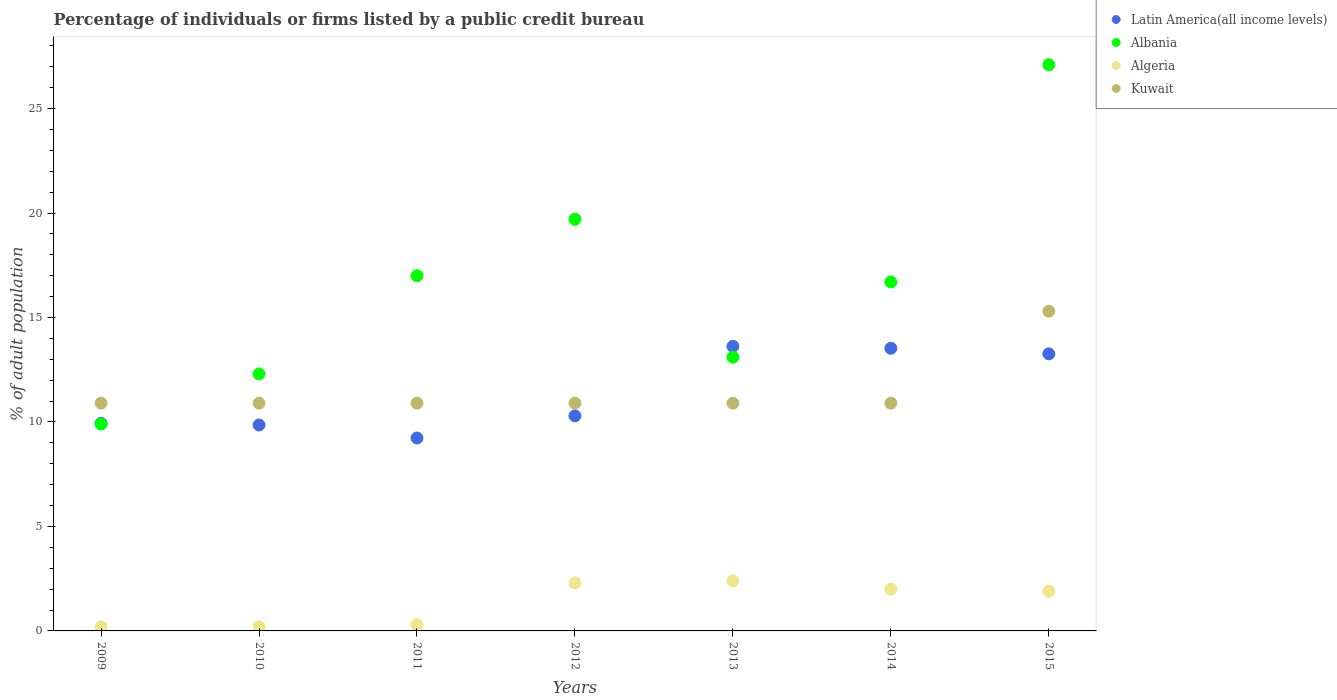Is the number of dotlines equal to the number of legend labels?
Give a very brief answer. Yes. Across all years, what is the maximum percentage of population listed by a public credit bureau in Albania?
Your answer should be very brief. 27.1. In which year was the percentage of population listed by a public credit bureau in Kuwait minimum?
Keep it short and to the point. 2009. What is the total percentage of population listed by a public credit bureau in Algeria in the graph?
Give a very brief answer. 9.3. What is the difference between the percentage of population listed by a public credit bureau in Latin America(all income levels) in 2011 and that in 2013?
Provide a succinct answer. -4.39. What is the difference between the percentage of population listed by a public credit bureau in Latin America(all income levels) in 2013 and the percentage of population listed by a public credit bureau in Albania in 2012?
Ensure brevity in your answer.  -6.08. What is the average percentage of population listed by a public credit bureau in Albania per year?
Ensure brevity in your answer.  16.54. In the year 2015, what is the difference between the percentage of population listed by a public credit bureau in Latin America(all income levels) and percentage of population listed by a public credit bureau in Albania?
Make the answer very short. -13.84. Is the difference between the percentage of population listed by a public credit bureau in Latin America(all income levels) in 2009 and 2014 greater than the difference between the percentage of population listed by a public credit bureau in Albania in 2009 and 2014?
Offer a terse response. Yes. What is the difference between the highest and the lowest percentage of population listed by a public credit bureau in Algeria?
Give a very brief answer. 2.2. Is the sum of the percentage of population listed by a public credit bureau in Kuwait in 2009 and 2012 greater than the maximum percentage of population listed by a public credit bureau in Algeria across all years?
Provide a short and direct response. Yes. Is it the case that in every year, the sum of the percentage of population listed by a public credit bureau in Kuwait and percentage of population listed by a public credit bureau in Latin America(all income levels)  is greater than the sum of percentage of population listed by a public credit bureau in Algeria and percentage of population listed by a public credit bureau in Albania?
Your answer should be compact. No. Is the percentage of population listed by a public credit bureau in Latin America(all income levels) strictly greater than the percentage of population listed by a public credit bureau in Albania over the years?
Give a very brief answer. No. Is the percentage of population listed by a public credit bureau in Kuwait strictly less than the percentage of population listed by a public credit bureau in Albania over the years?
Provide a succinct answer. No. How many years are there in the graph?
Your answer should be very brief. 7. Where does the legend appear in the graph?
Provide a short and direct response. Top right. What is the title of the graph?
Keep it short and to the point. Percentage of individuals or firms listed by a public credit bureau. What is the label or title of the X-axis?
Your answer should be very brief. Years. What is the label or title of the Y-axis?
Your answer should be compact. % of adult population. What is the % of adult population of Latin America(all income levels) in 2009?
Provide a short and direct response. 9.93. What is the % of adult population in Latin America(all income levels) in 2010?
Keep it short and to the point. 9.86. What is the % of adult population in Albania in 2010?
Offer a very short reply. 12.3. What is the % of adult population in Algeria in 2010?
Offer a very short reply. 0.2. What is the % of adult population in Kuwait in 2010?
Offer a very short reply. 10.9. What is the % of adult population of Latin America(all income levels) in 2011?
Your response must be concise. 9.23. What is the % of adult population in Kuwait in 2011?
Offer a terse response. 10.9. What is the % of adult population of Latin America(all income levels) in 2012?
Your answer should be very brief. 10.29. What is the % of adult population of Kuwait in 2012?
Offer a terse response. 10.9. What is the % of adult population in Latin America(all income levels) in 2013?
Provide a short and direct response. 13.62. What is the % of adult population of Albania in 2013?
Make the answer very short. 13.1. What is the % of adult population in Latin America(all income levels) in 2014?
Your response must be concise. 13.53. What is the % of adult population in Albania in 2014?
Offer a terse response. 16.7. What is the % of adult population of Algeria in 2014?
Keep it short and to the point. 2. What is the % of adult population in Kuwait in 2014?
Provide a short and direct response. 10.9. What is the % of adult population in Latin America(all income levels) in 2015?
Offer a very short reply. 13.26. What is the % of adult population of Albania in 2015?
Offer a very short reply. 27.1. Across all years, what is the maximum % of adult population in Latin America(all income levels)?
Give a very brief answer. 13.62. Across all years, what is the maximum % of adult population in Albania?
Your response must be concise. 27.1. Across all years, what is the maximum % of adult population in Algeria?
Your response must be concise. 2.4. Across all years, what is the maximum % of adult population in Kuwait?
Offer a very short reply. 15.3. Across all years, what is the minimum % of adult population of Latin America(all income levels)?
Your answer should be very brief. 9.23. Across all years, what is the minimum % of adult population in Albania?
Keep it short and to the point. 9.9. Across all years, what is the minimum % of adult population in Algeria?
Offer a terse response. 0.2. What is the total % of adult population of Latin America(all income levels) in the graph?
Keep it short and to the point. 79.72. What is the total % of adult population in Albania in the graph?
Offer a terse response. 115.8. What is the total % of adult population in Kuwait in the graph?
Ensure brevity in your answer.  80.7. What is the difference between the % of adult population of Latin America(all income levels) in 2009 and that in 2010?
Keep it short and to the point. 0.08. What is the difference between the % of adult population of Kuwait in 2009 and that in 2010?
Make the answer very short. 0. What is the difference between the % of adult population of Latin America(all income levels) in 2009 and that in 2011?
Your answer should be very brief. 0.7. What is the difference between the % of adult population of Albania in 2009 and that in 2011?
Provide a succinct answer. -7.1. What is the difference between the % of adult population in Latin America(all income levels) in 2009 and that in 2012?
Provide a short and direct response. -0.36. What is the difference between the % of adult population of Albania in 2009 and that in 2012?
Keep it short and to the point. -9.8. What is the difference between the % of adult population of Algeria in 2009 and that in 2012?
Provide a succinct answer. -2.1. What is the difference between the % of adult population in Latin America(all income levels) in 2009 and that in 2013?
Your answer should be compact. -3.68. What is the difference between the % of adult population of Latin America(all income levels) in 2009 and that in 2014?
Offer a very short reply. -3.59. What is the difference between the % of adult population of Algeria in 2009 and that in 2014?
Offer a terse response. -1.8. What is the difference between the % of adult population of Latin America(all income levels) in 2009 and that in 2015?
Keep it short and to the point. -3.33. What is the difference between the % of adult population of Albania in 2009 and that in 2015?
Provide a short and direct response. -17.2. What is the difference between the % of adult population of Algeria in 2009 and that in 2015?
Provide a succinct answer. -1.7. What is the difference between the % of adult population in Latin America(all income levels) in 2010 and that in 2011?
Offer a very short reply. 0.62. What is the difference between the % of adult population of Albania in 2010 and that in 2011?
Ensure brevity in your answer.  -4.7. What is the difference between the % of adult population of Latin America(all income levels) in 2010 and that in 2012?
Provide a short and direct response. -0.44. What is the difference between the % of adult population of Algeria in 2010 and that in 2012?
Your answer should be compact. -2.1. What is the difference between the % of adult population of Kuwait in 2010 and that in 2012?
Make the answer very short. 0. What is the difference between the % of adult population in Latin America(all income levels) in 2010 and that in 2013?
Your answer should be compact. -3.76. What is the difference between the % of adult population in Algeria in 2010 and that in 2013?
Provide a succinct answer. -2.2. What is the difference between the % of adult population in Kuwait in 2010 and that in 2013?
Give a very brief answer. 0. What is the difference between the % of adult population of Latin America(all income levels) in 2010 and that in 2014?
Your answer should be very brief. -3.67. What is the difference between the % of adult population in Latin America(all income levels) in 2010 and that in 2015?
Provide a succinct answer. -3.4. What is the difference between the % of adult population in Albania in 2010 and that in 2015?
Your response must be concise. -14.8. What is the difference between the % of adult population of Kuwait in 2010 and that in 2015?
Your answer should be very brief. -4.4. What is the difference between the % of adult population in Latin America(all income levels) in 2011 and that in 2012?
Provide a succinct answer. -1.06. What is the difference between the % of adult population of Latin America(all income levels) in 2011 and that in 2013?
Give a very brief answer. -4.39. What is the difference between the % of adult population of Latin America(all income levels) in 2011 and that in 2014?
Offer a very short reply. -4.29. What is the difference between the % of adult population of Algeria in 2011 and that in 2014?
Give a very brief answer. -1.7. What is the difference between the % of adult population in Kuwait in 2011 and that in 2014?
Offer a terse response. 0. What is the difference between the % of adult population of Latin America(all income levels) in 2011 and that in 2015?
Provide a short and direct response. -4.03. What is the difference between the % of adult population in Albania in 2011 and that in 2015?
Provide a succinct answer. -10.1. What is the difference between the % of adult population of Latin America(all income levels) in 2012 and that in 2013?
Give a very brief answer. -3.32. What is the difference between the % of adult population of Albania in 2012 and that in 2013?
Make the answer very short. 6.6. What is the difference between the % of adult population in Algeria in 2012 and that in 2013?
Ensure brevity in your answer.  -0.1. What is the difference between the % of adult population of Kuwait in 2012 and that in 2013?
Offer a very short reply. 0. What is the difference between the % of adult population in Latin America(all income levels) in 2012 and that in 2014?
Offer a terse response. -3.23. What is the difference between the % of adult population in Algeria in 2012 and that in 2014?
Keep it short and to the point. 0.3. What is the difference between the % of adult population of Latin America(all income levels) in 2012 and that in 2015?
Keep it short and to the point. -2.97. What is the difference between the % of adult population in Albania in 2012 and that in 2015?
Make the answer very short. -7.4. What is the difference between the % of adult population of Algeria in 2012 and that in 2015?
Provide a short and direct response. 0.4. What is the difference between the % of adult population in Latin America(all income levels) in 2013 and that in 2014?
Ensure brevity in your answer.  0.09. What is the difference between the % of adult population in Latin America(all income levels) in 2013 and that in 2015?
Ensure brevity in your answer.  0.36. What is the difference between the % of adult population in Albania in 2013 and that in 2015?
Give a very brief answer. -14. What is the difference between the % of adult population of Algeria in 2013 and that in 2015?
Your answer should be compact. 0.5. What is the difference between the % of adult population of Kuwait in 2013 and that in 2015?
Your response must be concise. -4.4. What is the difference between the % of adult population of Latin America(all income levels) in 2014 and that in 2015?
Your answer should be compact. 0.27. What is the difference between the % of adult population of Albania in 2014 and that in 2015?
Offer a terse response. -10.4. What is the difference between the % of adult population in Latin America(all income levels) in 2009 and the % of adult population in Albania in 2010?
Your answer should be very brief. -2.37. What is the difference between the % of adult population of Latin America(all income levels) in 2009 and the % of adult population of Algeria in 2010?
Ensure brevity in your answer.  9.73. What is the difference between the % of adult population in Latin America(all income levels) in 2009 and the % of adult population in Kuwait in 2010?
Offer a terse response. -0.97. What is the difference between the % of adult population of Albania in 2009 and the % of adult population of Kuwait in 2010?
Offer a terse response. -1. What is the difference between the % of adult population in Latin America(all income levels) in 2009 and the % of adult population in Albania in 2011?
Your answer should be very brief. -7.07. What is the difference between the % of adult population of Latin America(all income levels) in 2009 and the % of adult population of Algeria in 2011?
Offer a very short reply. 9.63. What is the difference between the % of adult population in Latin America(all income levels) in 2009 and the % of adult population in Kuwait in 2011?
Offer a very short reply. -0.97. What is the difference between the % of adult population of Albania in 2009 and the % of adult population of Kuwait in 2011?
Offer a very short reply. -1. What is the difference between the % of adult population of Algeria in 2009 and the % of adult population of Kuwait in 2011?
Your answer should be very brief. -10.7. What is the difference between the % of adult population of Latin America(all income levels) in 2009 and the % of adult population of Albania in 2012?
Keep it short and to the point. -9.77. What is the difference between the % of adult population of Latin America(all income levels) in 2009 and the % of adult population of Algeria in 2012?
Provide a short and direct response. 7.63. What is the difference between the % of adult population in Latin America(all income levels) in 2009 and the % of adult population in Kuwait in 2012?
Your response must be concise. -0.97. What is the difference between the % of adult population of Albania in 2009 and the % of adult population of Kuwait in 2012?
Offer a terse response. -1. What is the difference between the % of adult population in Algeria in 2009 and the % of adult population in Kuwait in 2012?
Offer a very short reply. -10.7. What is the difference between the % of adult population of Latin America(all income levels) in 2009 and the % of adult population of Albania in 2013?
Make the answer very short. -3.17. What is the difference between the % of adult population of Latin America(all income levels) in 2009 and the % of adult population of Algeria in 2013?
Provide a succinct answer. 7.53. What is the difference between the % of adult population in Latin America(all income levels) in 2009 and the % of adult population in Kuwait in 2013?
Offer a very short reply. -0.97. What is the difference between the % of adult population in Albania in 2009 and the % of adult population in Algeria in 2013?
Your answer should be very brief. 7.5. What is the difference between the % of adult population of Algeria in 2009 and the % of adult population of Kuwait in 2013?
Your answer should be compact. -10.7. What is the difference between the % of adult population in Latin America(all income levels) in 2009 and the % of adult population in Albania in 2014?
Make the answer very short. -6.77. What is the difference between the % of adult population of Latin America(all income levels) in 2009 and the % of adult population of Algeria in 2014?
Provide a succinct answer. 7.93. What is the difference between the % of adult population in Latin America(all income levels) in 2009 and the % of adult population in Kuwait in 2014?
Your response must be concise. -0.97. What is the difference between the % of adult population in Albania in 2009 and the % of adult population in Algeria in 2014?
Your answer should be compact. 7.9. What is the difference between the % of adult population in Latin America(all income levels) in 2009 and the % of adult population in Albania in 2015?
Ensure brevity in your answer.  -17.17. What is the difference between the % of adult population of Latin America(all income levels) in 2009 and the % of adult population of Algeria in 2015?
Make the answer very short. 8.03. What is the difference between the % of adult population of Latin America(all income levels) in 2009 and the % of adult population of Kuwait in 2015?
Offer a terse response. -5.37. What is the difference between the % of adult population in Albania in 2009 and the % of adult population in Algeria in 2015?
Your response must be concise. 8. What is the difference between the % of adult population in Algeria in 2009 and the % of adult population in Kuwait in 2015?
Ensure brevity in your answer.  -15.1. What is the difference between the % of adult population of Latin America(all income levels) in 2010 and the % of adult population of Albania in 2011?
Give a very brief answer. -7.14. What is the difference between the % of adult population of Latin America(all income levels) in 2010 and the % of adult population of Algeria in 2011?
Give a very brief answer. 9.56. What is the difference between the % of adult population of Latin America(all income levels) in 2010 and the % of adult population of Kuwait in 2011?
Make the answer very short. -1.04. What is the difference between the % of adult population of Albania in 2010 and the % of adult population of Kuwait in 2011?
Offer a very short reply. 1.4. What is the difference between the % of adult population of Algeria in 2010 and the % of adult population of Kuwait in 2011?
Keep it short and to the point. -10.7. What is the difference between the % of adult population in Latin America(all income levels) in 2010 and the % of adult population in Albania in 2012?
Give a very brief answer. -9.84. What is the difference between the % of adult population of Latin America(all income levels) in 2010 and the % of adult population of Algeria in 2012?
Your answer should be compact. 7.56. What is the difference between the % of adult population of Latin America(all income levels) in 2010 and the % of adult population of Kuwait in 2012?
Provide a succinct answer. -1.04. What is the difference between the % of adult population of Algeria in 2010 and the % of adult population of Kuwait in 2012?
Keep it short and to the point. -10.7. What is the difference between the % of adult population of Latin America(all income levels) in 2010 and the % of adult population of Albania in 2013?
Ensure brevity in your answer.  -3.24. What is the difference between the % of adult population in Latin America(all income levels) in 2010 and the % of adult population in Algeria in 2013?
Keep it short and to the point. 7.46. What is the difference between the % of adult population of Latin America(all income levels) in 2010 and the % of adult population of Kuwait in 2013?
Offer a terse response. -1.04. What is the difference between the % of adult population of Latin America(all income levels) in 2010 and the % of adult population of Albania in 2014?
Make the answer very short. -6.84. What is the difference between the % of adult population of Latin America(all income levels) in 2010 and the % of adult population of Algeria in 2014?
Your response must be concise. 7.86. What is the difference between the % of adult population of Latin America(all income levels) in 2010 and the % of adult population of Kuwait in 2014?
Ensure brevity in your answer.  -1.04. What is the difference between the % of adult population in Albania in 2010 and the % of adult population in Kuwait in 2014?
Ensure brevity in your answer.  1.4. What is the difference between the % of adult population of Latin America(all income levels) in 2010 and the % of adult population of Albania in 2015?
Give a very brief answer. -17.24. What is the difference between the % of adult population of Latin America(all income levels) in 2010 and the % of adult population of Algeria in 2015?
Provide a succinct answer. 7.96. What is the difference between the % of adult population of Latin America(all income levels) in 2010 and the % of adult population of Kuwait in 2015?
Give a very brief answer. -5.44. What is the difference between the % of adult population in Algeria in 2010 and the % of adult population in Kuwait in 2015?
Provide a short and direct response. -15.1. What is the difference between the % of adult population of Latin America(all income levels) in 2011 and the % of adult population of Albania in 2012?
Give a very brief answer. -10.47. What is the difference between the % of adult population of Latin America(all income levels) in 2011 and the % of adult population of Algeria in 2012?
Provide a short and direct response. 6.93. What is the difference between the % of adult population of Latin America(all income levels) in 2011 and the % of adult population of Kuwait in 2012?
Your response must be concise. -1.67. What is the difference between the % of adult population in Albania in 2011 and the % of adult population in Algeria in 2012?
Your response must be concise. 14.7. What is the difference between the % of adult population of Albania in 2011 and the % of adult population of Kuwait in 2012?
Provide a short and direct response. 6.1. What is the difference between the % of adult population of Algeria in 2011 and the % of adult population of Kuwait in 2012?
Your response must be concise. -10.6. What is the difference between the % of adult population in Latin America(all income levels) in 2011 and the % of adult population in Albania in 2013?
Your response must be concise. -3.87. What is the difference between the % of adult population of Latin America(all income levels) in 2011 and the % of adult population of Algeria in 2013?
Offer a very short reply. 6.83. What is the difference between the % of adult population in Latin America(all income levels) in 2011 and the % of adult population in Kuwait in 2013?
Your answer should be compact. -1.67. What is the difference between the % of adult population in Albania in 2011 and the % of adult population in Kuwait in 2013?
Your response must be concise. 6.1. What is the difference between the % of adult population in Latin America(all income levels) in 2011 and the % of adult population in Albania in 2014?
Your response must be concise. -7.47. What is the difference between the % of adult population in Latin America(all income levels) in 2011 and the % of adult population in Algeria in 2014?
Your answer should be very brief. 7.23. What is the difference between the % of adult population of Latin America(all income levels) in 2011 and the % of adult population of Kuwait in 2014?
Your answer should be very brief. -1.67. What is the difference between the % of adult population of Albania in 2011 and the % of adult population of Algeria in 2014?
Give a very brief answer. 15. What is the difference between the % of adult population in Algeria in 2011 and the % of adult population in Kuwait in 2014?
Give a very brief answer. -10.6. What is the difference between the % of adult population in Latin America(all income levels) in 2011 and the % of adult population in Albania in 2015?
Your answer should be compact. -17.87. What is the difference between the % of adult population in Latin America(all income levels) in 2011 and the % of adult population in Algeria in 2015?
Your answer should be very brief. 7.33. What is the difference between the % of adult population in Latin America(all income levels) in 2011 and the % of adult population in Kuwait in 2015?
Offer a terse response. -6.07. What is the difference between the % of adult population in Albania in 2011 and the % of adult population in Algeria in 2015?
Your answer should be very brief. 15.1. What is the difference between the % of adult population in Latin America(all income levels) in 2012 and the % of adult population in Albania in 2013?
Make the answer very short. -2.81. What is the difference between the % of adult population in Latin America(all income levels) in 2012 and the % of adult population in Algeria in 2013?
Provide a short and direct response. 7.89. What is the difference between the % of adult population in Latin America(all income levels) in 2012 and the % of adult population in Kuwait in 2013?
Make the answer very short. -0.61. What is the difference between the % of adult population of Algeria in 2012 and the % of adult population of Kuwait in 2013?
Offer a terse response. -8.6. What is the difference between the % of adult population of Latin America(all income levels) in 2012 and the % of adult population of Albania in 2014?
Your answer should be very brief. -6.41. What is the difference between the % of adult population of Latin America(all income levels) in 2012 and the % of adult population of Algeria in 2014?
Your answer should be compact. 8.29. What is the difference between the % of adult population of Latin America(all income levels) in 2012 and the % of adult population of Kuwait in 2014?
Provide a succinct answer. -0.61. What is the difference between the % of adult population of Albania in 2012 and the % of adult population of Algeria in 2014?
Your answer should be very brief. 17.7. What is the difference between the % of adult population of Albania in 2012 and the % of adult population of Kuwait in 2014?
Your answer should be compact. 8.8. What is the difference between the % of adult population of Algeria in 2012 and the % of adult population of Kuwait in 2014?
Ensure brevity in your answer.  -8.6. What is the difference between the % of adult population in Latin America(all income levels) in 2012 and the % of adult population in Albania in 2015?
Your answer should be compact. -16.81. What is the difference between the % of adult population of Latin America(all income levels) in 2012 and the % of adult population of Algeria in 2015?
Keep it short and to the point. 8.39. What is the difference between the % of adult population in Latin America(all income levels) in 2012 and the % of adult population in Kuwait in 2015?
Your answer should be very brief. -5.01. What is the difference between the % of adult population in Albania in 2012 and the % of adult population in Algeria in 2015?
Give a very brief answer. 17.8. What is the difference between the % of adult population of Albania in 2012 and the % of adult population of Kuwait in 2015?
Ensure brevity in your answer.  4.4. What is the difference between the % of adult population of Algeria in 2012 and the % of adult population of Kuwait in 2015?
Give a very brief answer. -13. What is the difference between the % of adult population of Latin America(all income levels) in 2013 and the % of adult population of Albania in 2014?
Provide a succinct answer. -3.08. What is the difference between the % of adult population of Latin America(all income levels) in 2013 and the % of adult population of Algeria in 2014?
Your response must be concise. 11.62. What is the difference between the % of adult population of Latin America(all income levels) in 2013 and the % of adult population of Kuwait in 2014?
Provide a succinct answer. 2.72. What is the difference between the % of adult population in Albania in 2013 and the % of adult population in Algeria in 2014?
Your answer should be compact. 11.1. What is the difference between the % of adult population of Albania in 2013 and the % of adult population of Kuwait in 2014?
Make the answer very short. 2.2. What is the difference between the % of adult population in Latin America(all income levels) in 2013 and the % of adult population in Albania in 2015?
Provide a short and direct response. -13.48. What is the difference between the % of adult population in Latin America(all income levels) in 2013 and the % of adult population in Algeria in 2015?
Offer a terse response. 11.72. What is the difference between the % of adult population in Latin America(all income levels) in 2013 and the % of adult population in Kuwait in 2015?
Give a very brief answer. -1.68. What is the difference between the % of adult population in Albania in 2013 and the % of adult population in Algeria in 2015?
Your answer should be compact. 11.2. What is the difference between the % of adult population in Algeria in 2013 and the % of adult population in Kuwait in 2015?
Offer a very short reply. -12.9. What is the difference between the % of adult population of Latin America(all income levels) in 2014 and the % of adult population of Albania in 2015?
Your response must be concise. -13.57. What is the difference between the % of adult population of Latin America(all income levels) in 2014 and the % of adult population of Algeria in 2015?
Your answer should be very brief. 11.63. What is the difference between the % of adult population in Latin America(all income levels) in 2014 and the % of adult population in Kuwait in 2015?
Your answer should be compact. -1.77. What is the difference between the % of adult population in Albania in 2014 and the % of adult population in Algeria in 2015?
Offer a very short reply. 14.8. What is the difference between the % of adult population of Albania in 2014 and the % of adult population of Kuwait in 2015?
Offer a terse response. 1.4. What is the average % of adult population in Latin America(all income levels) per year?
Give a very brief answer. 11.39. What is the average % of adult population in Albania per year?
Give a very brief answer. 16.54. What is the average % of adult population of Algeria per year?
Ensure brevity in your answer.  1.33. What is the average % of adult population of Kuwait per year?
Your answer should be compact. 11.53. In the year 2009, what is the difference between the % of adult population of Latin America(all income levels) and % of adult population of Albania?
Ensure brevity in your answer.  0.03. In the year 2009, what is the difference between the % of adult population in Latin America(all income levels) and % of adult population in Algeria?
Offer a very short reply. 9.73. In the year 2009, what is the difference between the % of adult population in Latin America(all income levels) and % of adult population in Kuwait?
Offer a terse response. -0.97. In the year 2009, what is the difference between the % of adult population of Albania and % of adult population of Kuwait?
Your answer should be compact. -1. In the year 2010, what is the difference between the % of adult population of Latin America(all income levels) and % of adult population of Albania?
Offer a very short reply. -2.44. In the year 2010, what is the difference between the % of adult population in Latin America(all income levels) and % of adult population in Algeria?
Provide a succinct answer. 9.66. In the year 2010, what is the difference between the % of adult population in Latin America(all income levels) and % of adult population in Kuwait?
Your answer should be very brief. -1.04. In the year 2010, what is the difference between the % of adult population of Albania and % of adult population of Kuwait?
Your answer should be compact. 1.4. In the year 2010, what is the difference between the % of adult population in Algeria and % of adult population in Kuwait?
Provide a short and direct response. -10.7. In the year 2011, what is the difference between the % of adult population of Latin America(all income levels) and % of adult population of Albania?
Give a very brief answer. -7.77. In the year 2011, what is the difference between the % of adult population of Latin America(all income levels) and % of adult population of Algeria?
Provide a succinct answer. 8.93. In the year 2011, what is the difference between the % of adult population in Latin America(all income levels) and % of adult population in Kuwait?
Keep it short and to the point. -1.67. In the year 2011, what is the difference between the % of adult population of Algeria and % of adult population of Kuwait?
Offer a terse response. -10.6. In the year 2012, what is the difference between the % of adult population in Latin America(all income levels) and % of adult population in Albania?
Your response must be concise. -9.41. In the year 2012, what is the difference between the % of adult population in Latin America(all income levels) and % of adult population in Algeria?
Provide a succinct answer. 7.99. In the year 2012, what is the difference between the % of adult population in Latin America(all income levels) and % of adult population in Kuwait?
Offer a terse response. -0.61. In the year 2012, what is the difference between the % of adult population of Albania and % of adult population of Algeria?
Offer a very short reply. 17.4. In the year 2012, what is the difference between the % of adult population in Albania and % of adult population in Kuwait?
Offer a very short reply. 8.8. In the year 2012, what is the difference between the % of adult population of Algeria and % of adult population of Kuwait?
Make the answer very short. -8.6. In the year 2013, what is the difference between the % of adult population in Latin America(all income levels) and % of adult population in Albania?
Your answer should be compact. 0.52. In the year 2013, what is the difference between the % of adult population of Latin America(all income levels) and % of adult population of Algeria?
Give a very brief answer. 11.22. In the year 2013, what is the difference between the % of adult population in Latin America(all income levels) and % of adult population in Kuwait?
Your answer should be very brief. 2.72. In the year 2013, what is the difference between the % of adult population of Albania and % of adult population of Algeria?
Your response must be concise. 10.7. In the year 2014, what is the difference between the % of adult population of Latin America(all income levels) and % of adult population of Albania?
Offer a very short reply. -3.17. In the year 2014, what is the difference between the % of adult population in Latin America(all income levels) and % of adult population in Algeria?
Ensure brevity in your answer.  11.53. In the year 2014, what is the difference between the % of adult population of Latin America(all income levels) and % of adult population of Kuwait?
Give a very brief answer. 2.63. In the year 2014, what is the difference between the % of adult population of Albania and % of adult population of Algeria?
Make the answer very short. 14.7. In the year 2014, what is the difference between the % of adult population in Albania and % of adult population in Kuwait?
Offer a very short reply. 5.8. In the year 2015, what is the difference between the % of adult population in Latin America(all income levels) and % of adult population in Albania?
Offer a very short reply. -13.84. In the year 2015, what is the difference between the % of adult population of Latin America(all income levels) and % of adult population of Algeria?
Offer a terse response. 11.36. In the year 2015, what is the difference between the % of adult population of Latin America(all income levels) and % of adult population of Kuwait?
Offer a terse response. -2.04. In the year 2015, what is the difference between the % of adult population in Albania and % of adult population in Algeria?
Offer a very short reply. 25.2. In the year 2015, what is the difference between the % of adult population of Algeria and % of adult population of Kuwait?
Offer a very short reply. -13.4. What is the ratio of the % of adult population in Latin America(all income levels) in 2009 to that in 2010?
Make the answer very short. 1.01. What is the ratio of the % of adult population in Albania in 2009 to that in 2010?
Provide a succinct answer. 0.8. What is the ratio of the % of adult population in Algeria in 2009 to that in 2010?
Ensure brevity in your answer.  1. What is the ratio of the % of adult population of Kuwait in 2009 to that in 2010?
Your answer should be compact. 1. What is the ratio of the % of adult population in Latin America(all income levels) in 2009 to that in 2011?
Offer a terse response. 1.08. What is the ratio of the % of adult population of Albania in 2009 to that in 2011?
Offer a terse response. 0.58. What is the ratio of the % of adult population of Kuwait in 2009 to that in 2011?
Ensure brevity in your answer.  1. What is the ratio of the % of adult population of Latin America(all income levels) in 2009 to that in 2012?
Your response must be concise. 0.96. What is the ratio of the % of adult population of Albania in 2009 to that in 2012?
Give a very brief answer. 0.5. What is the ratio of the % of adult population in Algeria in 2009 to that in 2012?
Your response must be concise. 0.09. What is the ratio of the % of adult population in Kuwait in 2009 to that in 2012?
Ensure brevity in your answer.  1. What is the ratio of the % of adult population of Latin America(all income levels) in 2009 to that in 2013?
Keep it short and to the point. 0.73. What is the ratio of the % of adult population in Albania in 2009 to that in 2013?
Your answer should be very brief. 0.76. What is the ratio of the % of adult population in Algeria in 2009 to that in 2013?
Provide a succinct answer. 0.08. What is the ratio of the % of adult population of Latin America(all income levels) in 2009 to that in 2014?
Your answer should be compact. 0.73. What is the ratio of the % of adult population in Albania in 2009 to that in 2014?
Your response must be concise. 0.59. What is the ratio of the % of adult population in Kuwait in 2009 to that in 2014?
Provide a succinct answer. 1. What is the ratio of the % of adult population of Latin America(all income levels) in 2009 to that in 2015?
Provide a succinct answer. 0.75. What is the ratio of the % of adult population in Albania in 2009 to that in 2015?
Your answer should be very brief. 0.37. What is the ratio of the % of adult population of Algeria in 2009 to that in 2015?
Your answer should be very brief. 0.11. What is the ratio of the % of adult population of Kuwait in 2009 to that in 2015?
Your answer should be very brief. 0.71. What is the ratio of the % of adult population of Latin America(all income levels) in 2010 to that in 2011?
Ensure brevity in your answer.  1.07. What is the ratio of the % of adult population in Albania in 2010 to that in 2011?
Your answer should be very brief. 0.72. What is the ratio of the % of adult population in Kuwait in 2010 to that in 2011?
Make the answer very short. 1. What is the ratio of the % of adult population in Latin America(all income levels) in 2010 to that in 2012?
Keep it short and to the point. 0.96. What is the ratio of the % of adult population of Albania in 2010 to that in 2012?
Your answer should be very brief. 0.62. What is the ratio of the % of adult population in Algeria in 2010 to that in 2012?
Ensure brevity in your answer.  0.09. What is the ratio of the % of adult population in Latin America(all income levels) in 2010 to that in 2013?
Your answer should be compact. 0.72. What is the ratio of the % of adult population of Albania in 2010 to that in 2013?
Give a very brief answer. 0.94. What is the ratio of the % of adult population of Algeria in 2010 to that in 2013?
Offer a terse response. 0.08. What is the ratio of the % of adult population in Kuwait in 2010 to that in 2013?
Your answer should be compact. 1. What is the ratio of the % of adult population of Latin America(all income levels) in 2010 to that in 2014?
Your response must be concise. 0.73. What is the ratio of the % of adult population of Albania in 2010 to that in 2014?
Offer a very short reply. 0.74. What is the ratio of the % of adult population in Latin America(all income levels) in 2010 to that in 2015?
Your answer should be very brief. 0.74. What is the ratio of the % of adult population in Albania in 2010 to that in 2015?
Your response must be concise. 0.45. What is the ratio of the % of adult population in Algeria in 2010 to that in 2015?
Provide a short and direct response. 0.11. What is the ratio of the % of adult population of Kuwait in 2010 to that in 2015?
Offer a terse response. 0.71. What is the ratio of the % of adult population of Latin America(all income levels) in 2011 to that in 2012?
Make the answer very short. 0.9. What is the ratio of the % of adult population in Albania in 2011 to that in 2012?
Your answer should be very brief. 0.86. What is the ratio of the % of adult population in Algeria in 2011 to that in 2012?
Your answer should be very brief. 0.13. What is the ratio of the % of adult population in Latin America(all income levels) in 2011 to that in 2013?
Your answer should be compact. 0.68. What is the ratio of the % of adult population in Albania in 2011 to that in 2013?
Provide a succinct answer. 1.3. What is the ratio of the % of adult population in Latin America(all income levels) in 2011 to that in 2014?
Offer a terse response. 0.68. What is the ratio of the % of adult population of Latin America(all income levels) in 2011 to that in 2015?
Give a very brief answer. 0.7. What is the ratio of the % of adult population of Albania in 2011 to that in 2015?
Your response must be concise. 0.63. What is the ratio of the % of adult population in Algeria in 2011 to that in 2015?
Ensure brevity in your answer.  0.16. What is the ratio of the % of adult population in Kuwait in 2011 to that in 2015?
Keep it short and to the point. 0.71. What is the ratio of the % of adult population of Latin America(all income levels) in 2012 to that in 2013?
Make the answer very short. 0.76. What is the ratio of the % of adult population of Albania in 2012 to that in 2013?
Keep it short and to the point. 1.5. What is the ratio of the % of adult population of Latin America(all income levels) in 2012 to that in 2014?
Provide a short and direct response. 0.76. What is the ratio of the % of adult population in Albania in 2012 to that in 2014?
Provide a succinct answer. 1.18. What is the ratio of the % of adult population in Algeria in 2012 to that in 2014?
Give a very brief answer. 1.15. What is the ratio of the % of adult population of Kuwait in 2012 to that in 2014?
Provide a succinct answer. 1. What is the ratio of the % of adult population of Latin America(all income levels) in 2012 to that in 2015?
Your response must be concise. 0.78. What is the ratio of the % of adult population in Albania in 2012 to that in 2015?
Provide a succinct answer. 0.73. What is the ratio of the % of adult population of Algeria in 2012 to that in 2015?
Offer a terse response. 1.21. What is the ratio of the % of adult population of Kuwait in 2012 to that in 2015?
Make the answer very short. 0.71. What is the ratio of the % of adult population in Latin America(all income levels) in 2013 to that in 2014?
Provide a succinct answer. 1.01. What is the ratio of the % of adult population of Albania in 2013 to that in 2014?
Provide a short and direct response. 0.78. What is the ratio of the % of adult population in Kuwait in 2013 to that in 2014?
Keep it short and to the point. 1. What is the ratio of the % of adult population of Albania in 2013 to that in 2015?
Provide a short and direct response. 0.48. What is the ratio of the % of adult population of Algeria in 2013 to that in 2015?
Ensure brevity in your answer.  1.26. What is the ratio of the % of adult population in Kuwait in 2013 to that in 2015?
Your answer should be compact. 0.71. What is the ratio of the % of adult population of Latin America(all income levels) in 2014 to that in 2015?
Provide a succinct answer. 1.02. What is the ratio of the % of adult population of Albania in 2014 to that in 2015?
Offer a terse response. 0.62. What is the ratio of the % of adult population of Algeria in 2014 to that in 2015?
Give a very brief answer. 1.05. What is the ratio of the % of adult population in Kuwait in 2014 to that in 2015?
Keep it short and to the point. 0.71. What is the difference between the highest and the second highest % of adult population of Latin America(all income levels)?
Offer a terse response. 0.09. What is the difference between the highest and the lowest % of adult population in Latin America(all income levels)?
Offer a terse response. 4.39. 